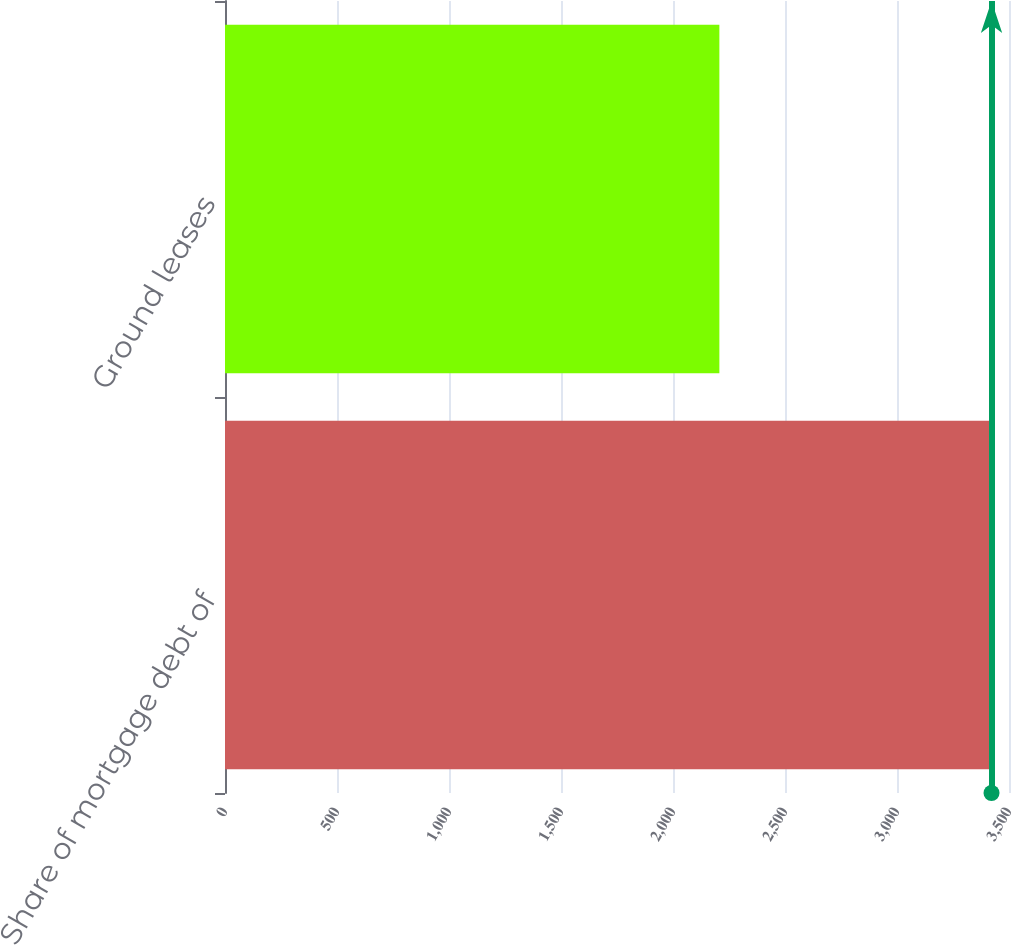Convert chart to OTSL. <chart><loc_0><loc_0><loc_500><loc_500><bar_chart><fcel>Share of mortgage debt of<fcel>Ground leases<nl><fcel>3422<fcel>2207<nl></chart> 